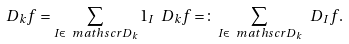Convert formula to latex. <formula><loc_0><loc_0><loc_500><loc_500>\ D _ { k } f = \sum _ { I \in \ m a t h s c r { D } _ { k } } 1 _ { I } \ D _ { k } f = \colon \sum _ { I \in \ m a t h s c r { D } _ { k } } \ D _ { I } f .</formula> 